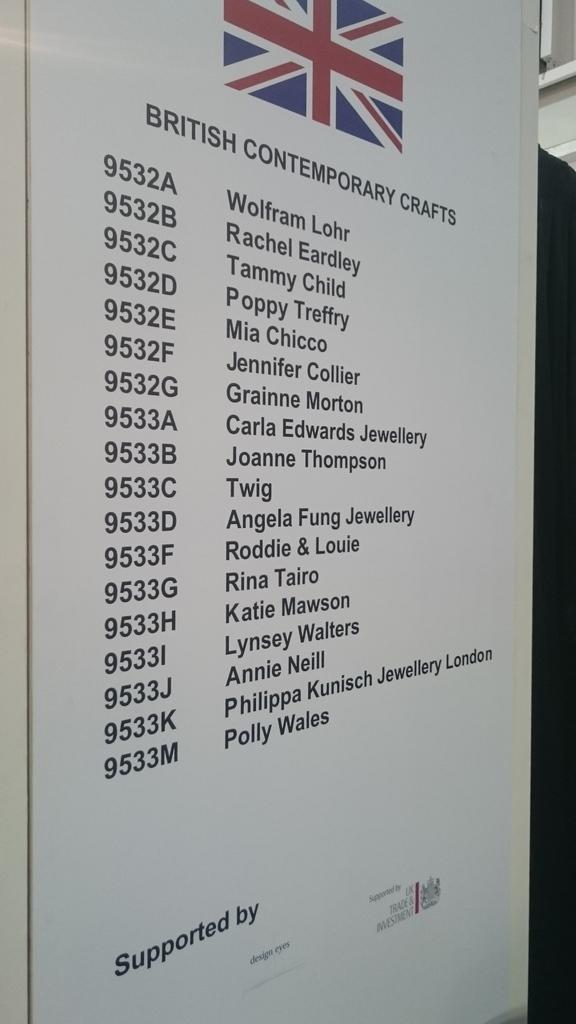<image>
Summarize the visual content of the image. a Great Britain flag with the name Wolfram Lohr at the top 